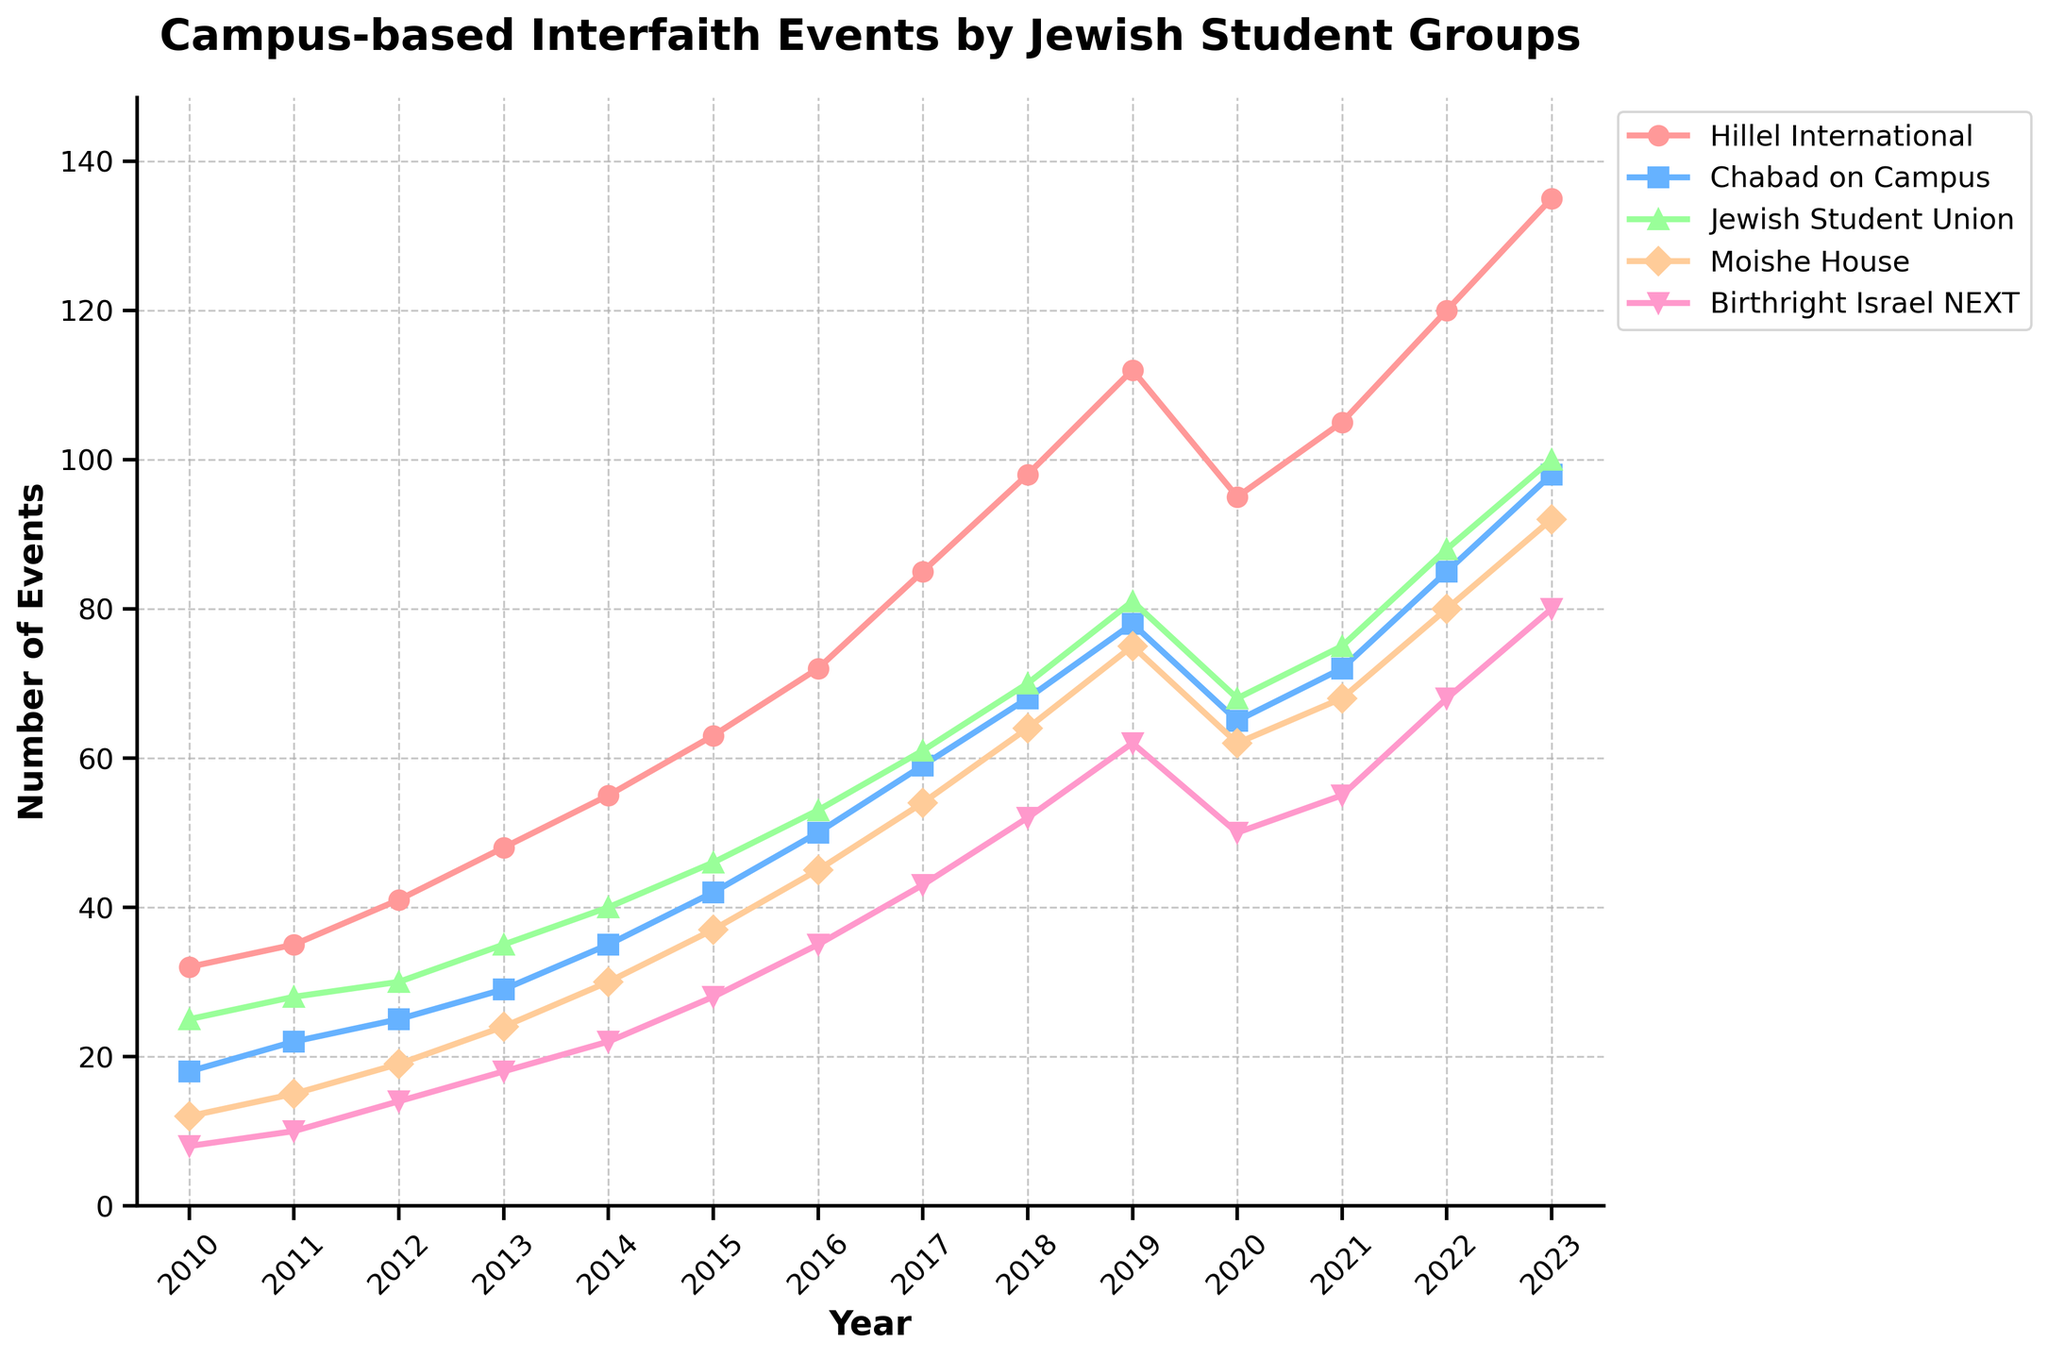Which Jewish student group hosted the most interfaith events in 2023? In 2023, the group with the highest data point is Hillel International.
Answer: Hillel International Which student group showed the highest increase in the number of events from 2010 to 2023? Calculating the increase for each group from 2010 to 2023:
- Hillel International: 135 - 32 = 103
- Chabad on Campus: 98 - 18 = 80
- Jewish Student Union: 100 - 25 = 75
- Moishe House: 92 - 12 = 80
- Birthright Israel NEXT: 80 - 8 = 72
Hillel International had the highest increase.
Answer: Hillel International What was the combined number of events hosted by all groups in 2020? Summing the 2020 values: 95 + 65 + 68 + 62 + 50 = 340
Answer: 340 Which year had the biggest decrease in events for Hillel International? Hillel International decreased from 112 events in 2019 to 95 in 2020, which is a decrease of 17, the largest drop in any year for Hillel.
Answer: 2020 Which group showed the least variability in the number of hosted events over the entire period? Based on visual inspection, Birthright Israel NEXT shows the least steep changes and appears to have the least variability.
Answer: Birthright Israel NEXT Between 2012 and 2017, which group saw the largest increase in the number of hosted events? Calculating the increase for each group from 2012 to 2017:
- Hillel International: 85 - 41 = 44
- Chabad on Campus: 59 - 25 = 34
- Jewish Student Union: 61 - 30 = 31
- Moishe House: 54 - 19 = 35
- Birthright Israel NEXT: 43 - 14 = 29
Hillel International had the largest increase.
Answer: Hillel International In which year did Chabad on Campus first host more than 50 events? Checking the values, Chabad on Campus first hosted more than 50 events in 2016.
Answer: 2016 What is the average number of interfaith events hosted by the Jewish Student Union from 2010 to 2023? Calculate the average by summing all values and dividing by the number of years: (25 + 28 + 30 + 35 + 40 + 46 + 53 + 61 + 70 + 81 + 68 + 75 + 88 + 100) / 14 = 689 / 14 ≈ 49.21
Answer: 49.21 How many years did it take for Moishe House to go from hosting 15 to 45 events annually? Moishe House hosted 15 events in 2011 and 45 events in 2016, taking 5 years to reach that number.
Answer: 5 During which years did Birthright Israel NEXT see a consistent increase without any decrease? Birthright Israel NEXT saw consistent increases from 2010 (8) to 2014 (22) and from 2016 (35) to 2023 (80).
Answer: 2010-2014 and 2016-2023 